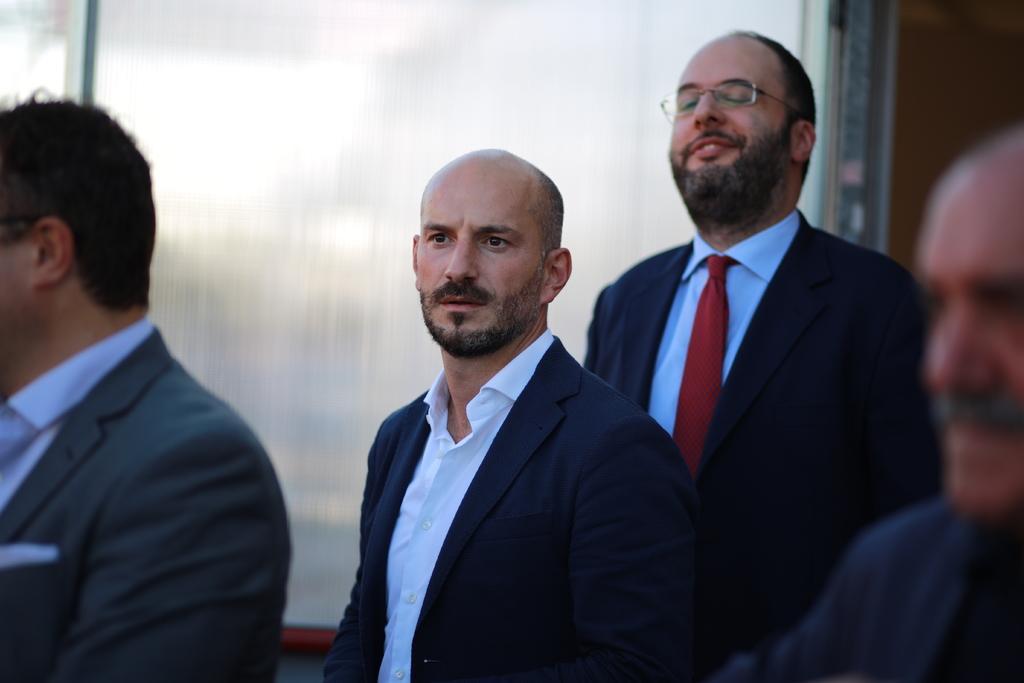Can you describe this image briefly? These three people wore suits. This man wore tie and spectacles. 